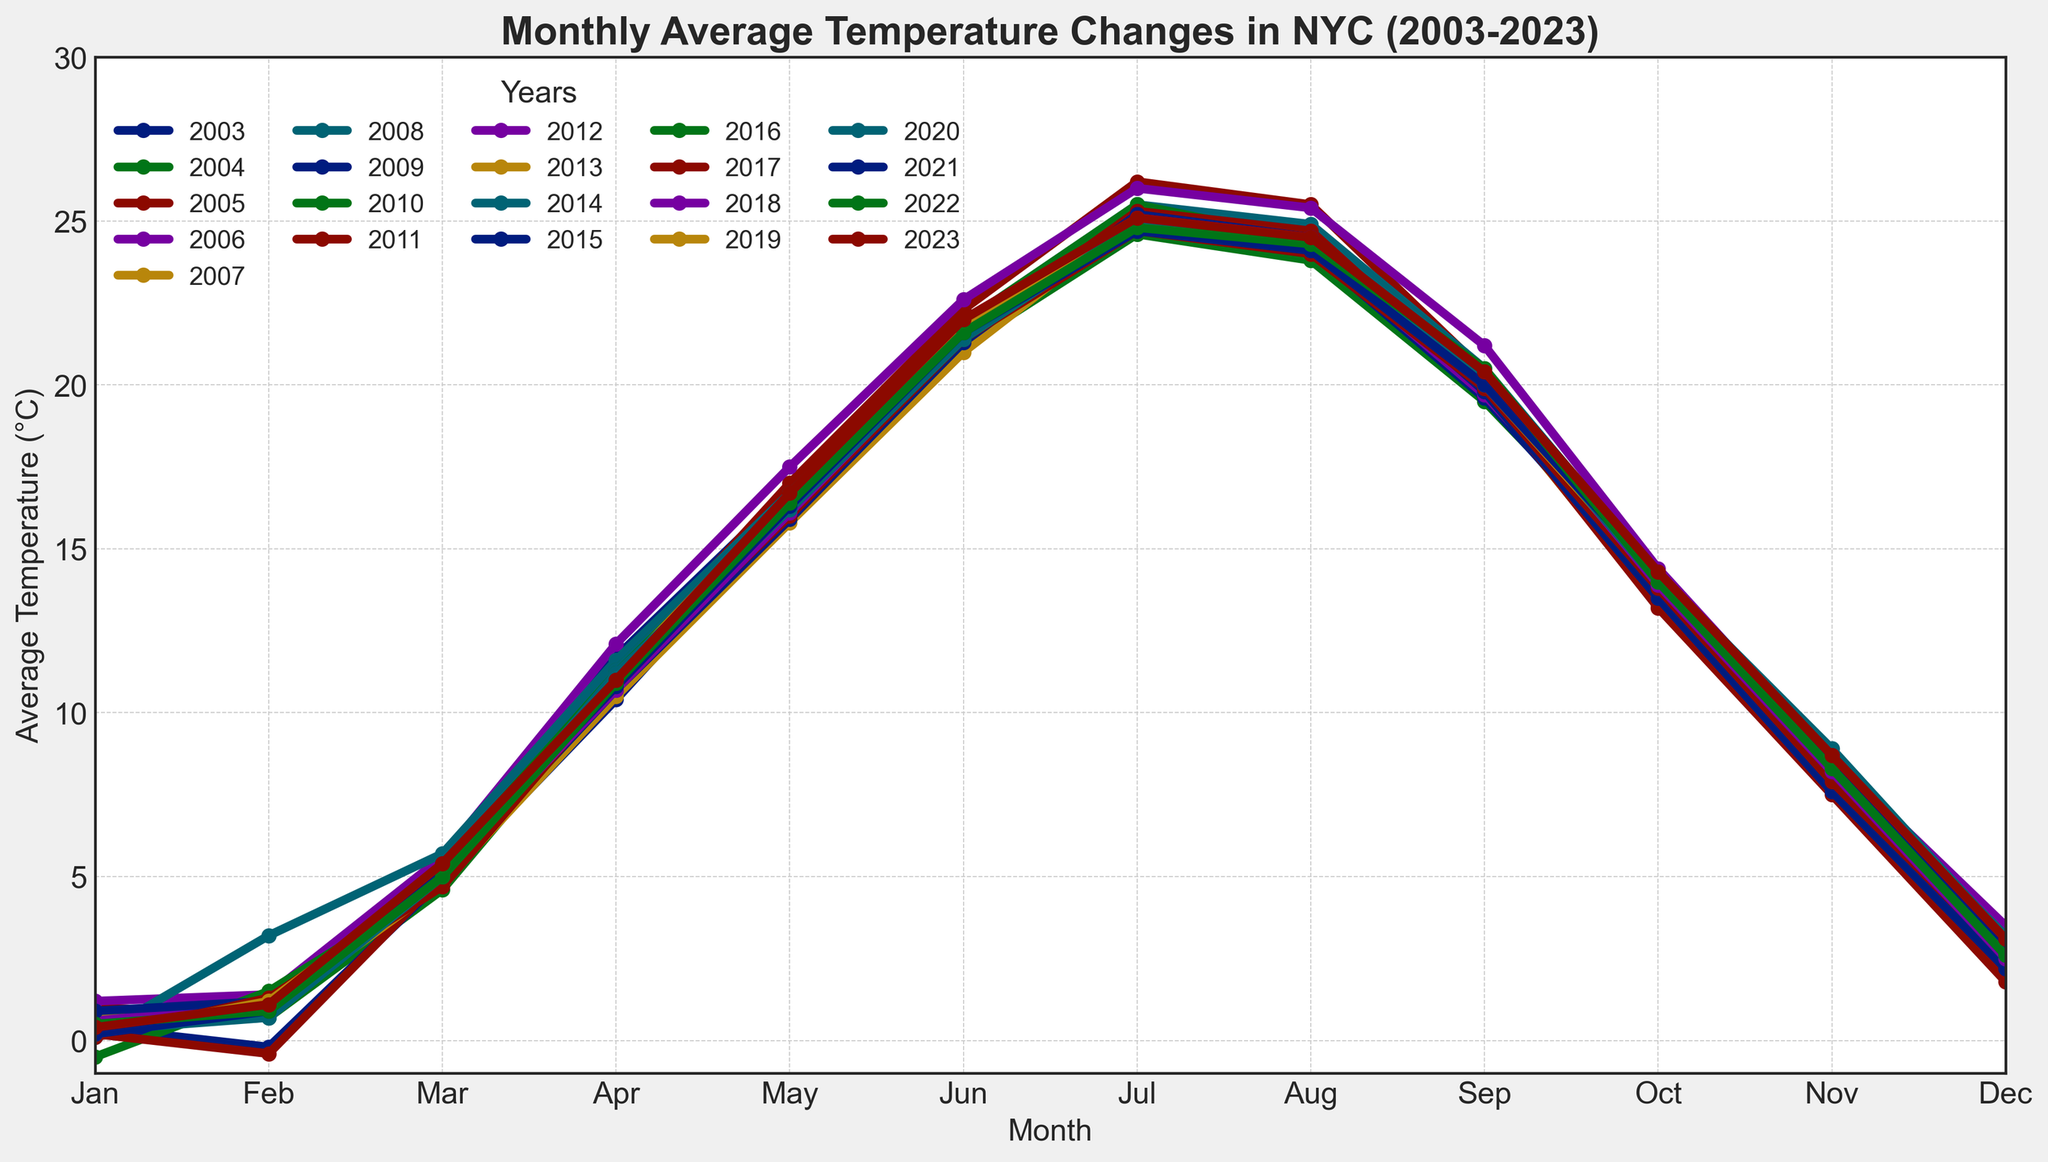Which month typically shows the highest average temperature across 2003-2023? By observing the peaks of the plot for each year, July often shows the highest average temperature.
Answer: July What is the average temperature in January for the entire period 2003-2023? Calculate the average of the temperatures for each January from 2003 to 2023. Sum all January averages and divide by the number of years (21). The calculation is (0.3+0.5+1.0+1.2+0.8+0.1+0.4+0.9+0.4+1.0-0.5+0.2+0.6+0.3+0.4+0.9+0.4+0.1+0.2+0.5+0.3+0.4)/21 = (11.3/21)
Answer: 0.54°C Which year had the coldest February? By comparing the February data points for each year on the graph, we find that 2009 had the coldest February with a temperature of -0.2°C.
Answer: 2009 Does the graph show any year where November's temperature is higher than May's? If so, which year? Compare the data points for May and November for all years to identify any instance where November's temperature exceeds May's. There are no such instances visible in the graph.
Answer: No Which year recorded the hottest August and what was the temperature? Identify the peak temperature in August for the entire period, noted on the chart. 2008 recorded the hottest August at 24.9°C.
Answer: 2008, 24.9°C In which year did September have a significantly higher or lower average temperature compared to the overall trend? Identify the year where the September temperature stands out the most from the norm. 2009 had a relatively lower temperature at 19.6°C, compared to other years around 20°C-21°C.
Answer: 2009 